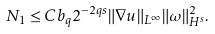Convert formula to latex. <formula><loc_0><loc_0><loc_500><loc_500>N _ { 1 } \leq C b _ { q } 2 ^ { - 2 q s } \| \nabla u \| _ { L ^ { \infty } } \| \omega \| _ { H ^ { s } } ^ { 2 } .</formula> 